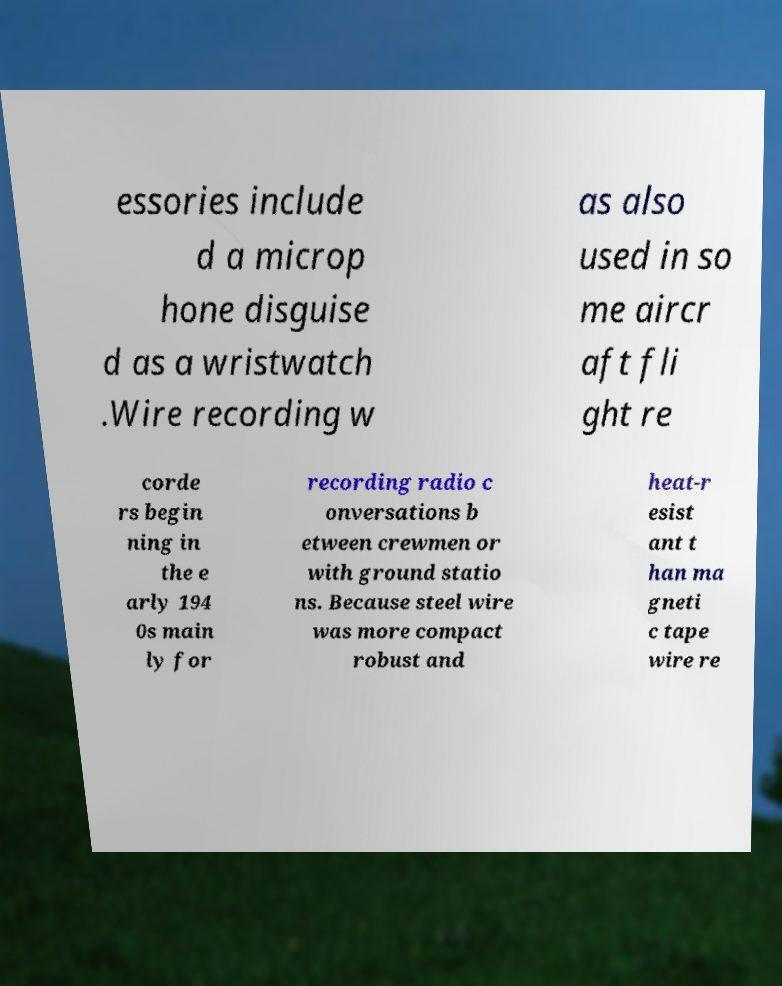Could you assist in decoding the text presented in this image and type it out clearly? essories include d a microp hone disguise d as a wristwatch .Wire recording w as also used in so me aircr aft fli ght re corde rs begin ning in the e arly 194 0s main ly for recording radio c onversations b etween crewmen or with ground statio ns. Because steel wire was more compact robust and heat-r esist ant t han ma gneti c tape wire re 